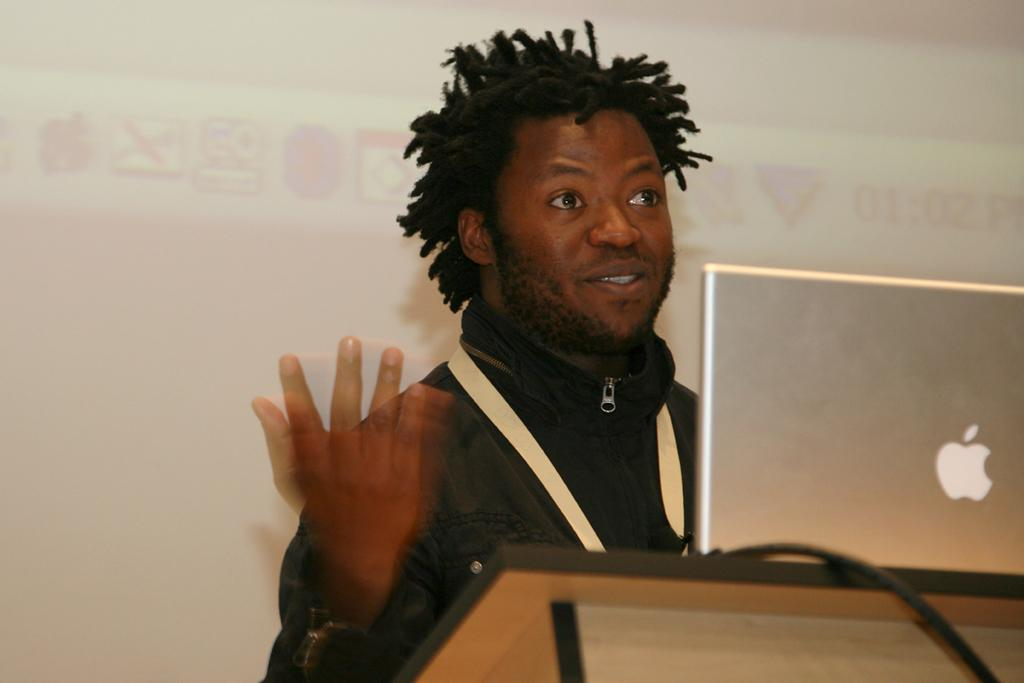What is the person in the image doing? The person is standing behind a podium. What object is on the podium with the person? There is a laptop on the podium. What color is the background in the image? The background is white. What type of record is being played in the image? There is no record or music player present in the image. What action is the person taking with their voice in the image? The image does not show any action involving the person's voice. 